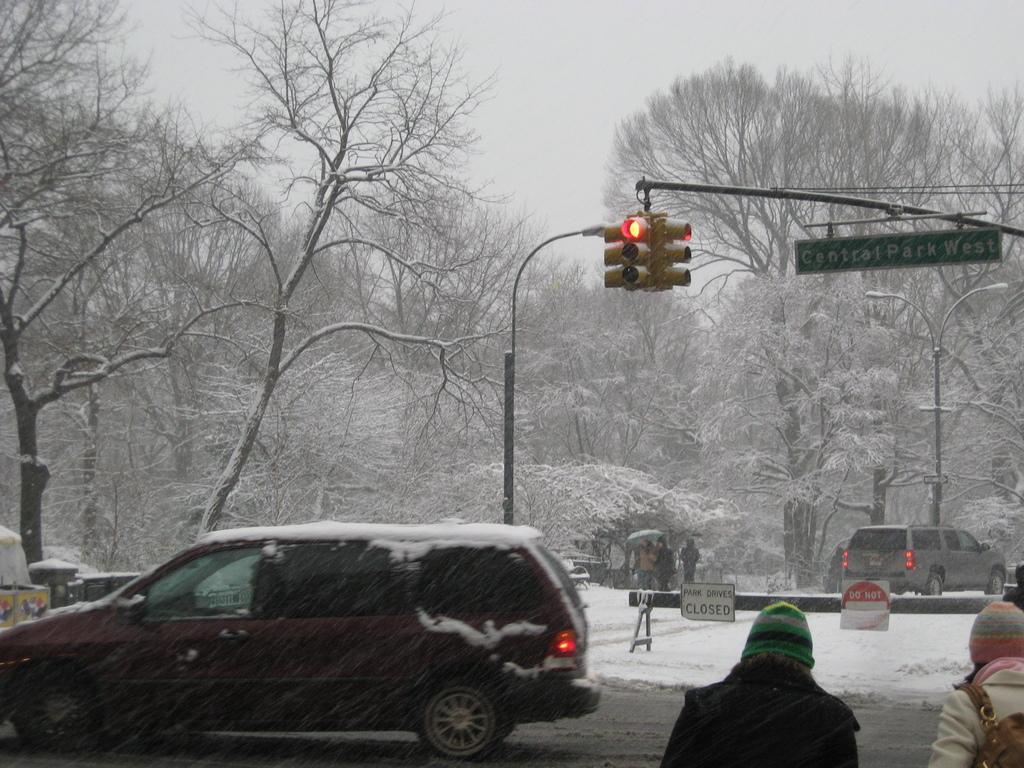How would you summarize this image in a sentence or two? This picture is clicked outside the city. At the bottom of the picture, we see a car is moving on the road. In the right bottom of the picture, we see two women are walking on the road. In the middle of the picture, we see traffic signals and a pole. We see boards in white and green color with some text written on it. We see people are walking on the road. Beside that, we see a car is moving on the road. There are trees in the background. These trees are covered with the snow. 